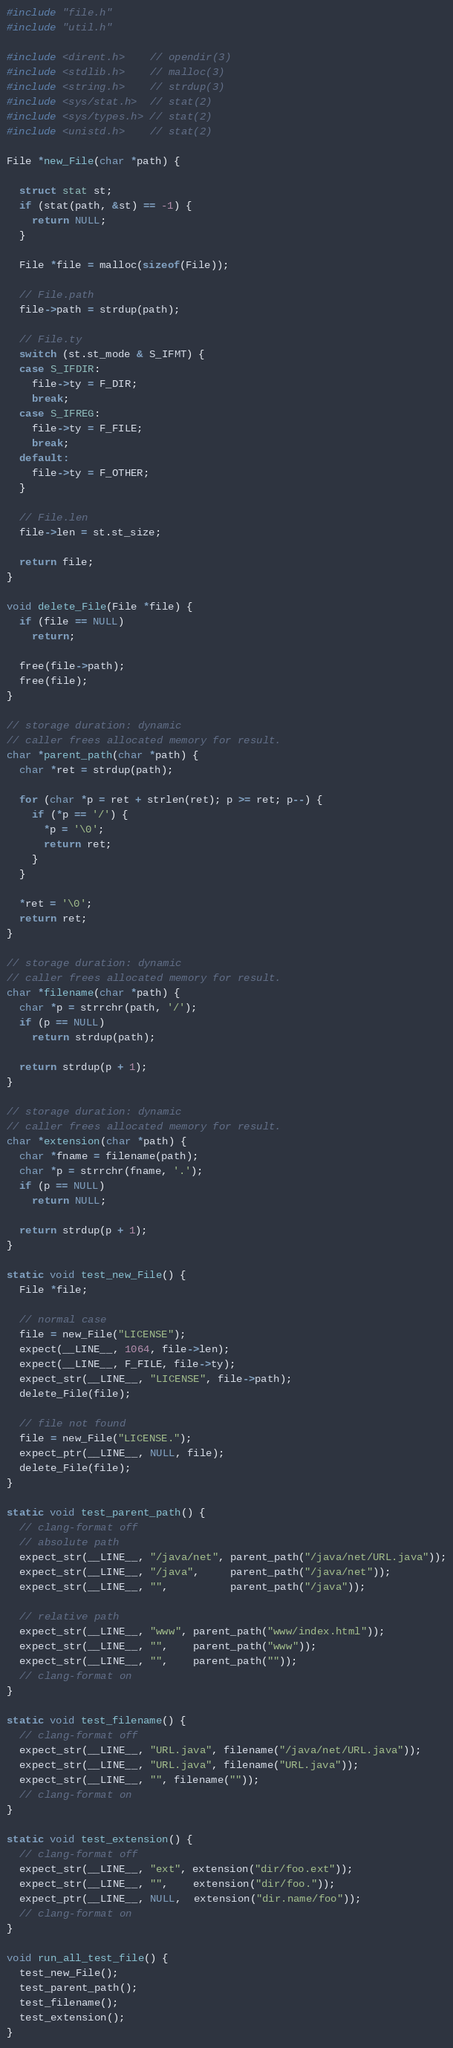Convert code to text. <code><loc_0><loc_0><loc_500><loc_500><_C_>#include "file.h"
#include "util.h"

#include <dirent.h>    // opendir(3)
#include <stdlib.h>    // malloc(3)
#include <string.h>    // strdup(3)
#include <sys/stat.h>  // stat(2)
#include <sys/types.h> // stat(2)
#include <unistd.h>    // stat(2)

File *new_File(char *path) {

  struct stat st;
  if (stat(path, &st) == -1) {
    return NULL;
  }

  File *file = malloc(sizeof(File));

  // File.path
  file->path = strdup(path);

  // File.ty
  switch (st.st_mode & S_IFMT) {
  case S_IFDIR:
    file->ty = F_DIR;
    break;
  case S_IFREG:
    file->ty = F_FILE;
    break;
  default:
    file->ty = F_OTHER;
  }

  // File.len
  file->len = st.st_size;

  return file;
}

void delete_File(File *file) {
  if (file == NULL)
    return;

  free(file->path);
  free(file);
}

// storage duration: dynamic
// caller frees allocated memory for result.
char *parent_path(char *path) {
  char *ret = strdup(path);

  for (char *p = ret + strlen(ret); p >= ret; p--) {
    if (*p == '/') {
      *p = '\0';
      return ret;
    }
  }

  *ret = '\0';
  return ret;
}

// storage duration: dynamic
// caller frees allocated memory for result.
char *filename(char *path) {
  char *p = strrchr(path, '/');
  if (p == NULL)
    return strdup(path);

  return strdup(p + 1);
}

// storage duration: dynamic
// caller frees allocated memory for result.
char *extension(char *path) {
  char *fname = filename(path);
  char *p = strrchr(fname, '.');
  if (p == NULL)
    return NULL;

  return strdup(p + 1);
}

static void test_new_File() {
  File *file;

  // normal case
  file = new_File("LICENSE");
  expect(__LINE__, 1064, file->len);
  expect(__LINE__, F_FILE, file->ty);
  expect_str(__LINE__, "LICENSE", file->path);
  delete_File(file);

  // file not found
  file = new_File("LICENSE.");
  expect_ptr(__LINE__, NULL, file);
  delete_File(file);
}

static void test_parent_path() {
  // clang-format off
  // absolute path
  expect_str(__LINE__, "/java/net", parent_path("/java/net/URL.java"));
  expect_str(__LINE__, "/java",     parent_path("/java/net"));
  expect_str(__LINE__, "",          parent_path("/java"));

  // relative path
  expect_str(__LINE__, "www", parent_path("www/index.html"));
  expect_str(__LINE__, "",    parent_path("www"));
  expect_str(__LINE__, "",    parent_path(""));
  // clang-format on
}

static void test_filename() {
  // clang-format off
  expect_str(__LINE__, "URL.java", filename("/java/net/URL.java"));
  expect_str(__LINE__, "URL.java", filename("URL.java"));
  expect_str(__LINE__, "", filename(""));
  // clang-format on
}

static void test_extension() {
  // clang-format off
  expect_str(__LINE__, "ext", extension("dir/foo.ext"));
  expect_str(__LINE__, "",    extension("dir/foo."));
  expect_ptr(__LINE__, NULL,  extension("dir.name/foo"));
  // clang-format on
}

void run_all_test_file() {
  test_new_File();
  test_parent_path();
  test_filename();
  test_extension();
}
</code> 